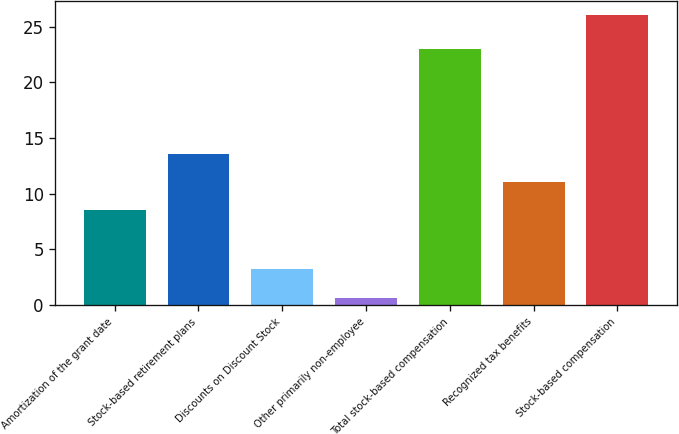<chart> <loc_0><loc_0><loc_500><loc_500><bar_chart><fcel>Amortization of the grant date<fcel>Stock-based retirement plans<fcel>Discounts on Discount Stock<fcel>Other primarily non-employee<fcel>Total stock-based compensation<fcel>Recognized tax benefits<fcel>Stock-based compensation<nl><fcel>8.5<fcel>13.58<fcel>3.2<fcel>0.6<fcel>23<fcel>11.04<fcel>26<nl></chart> 